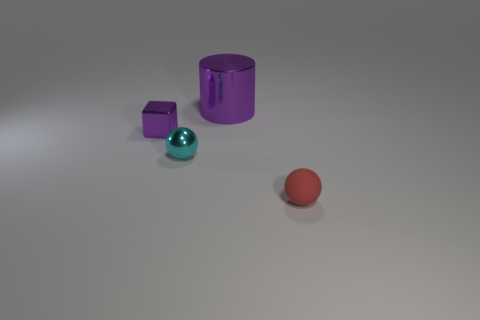Add 3 gray blocks. How many objects exist? 7 Subtract all blocks. How many objects are left? 3 Add 3 matte things. How many matte things exist? 4 Subtract 0 green blocks. How many objects are left? 4 Subtract all small cyan metal things. Subtract all tiny purple metallic cubes. How many objects are left? 2 Add 2 small blocks. How many small blocks are left? 3 